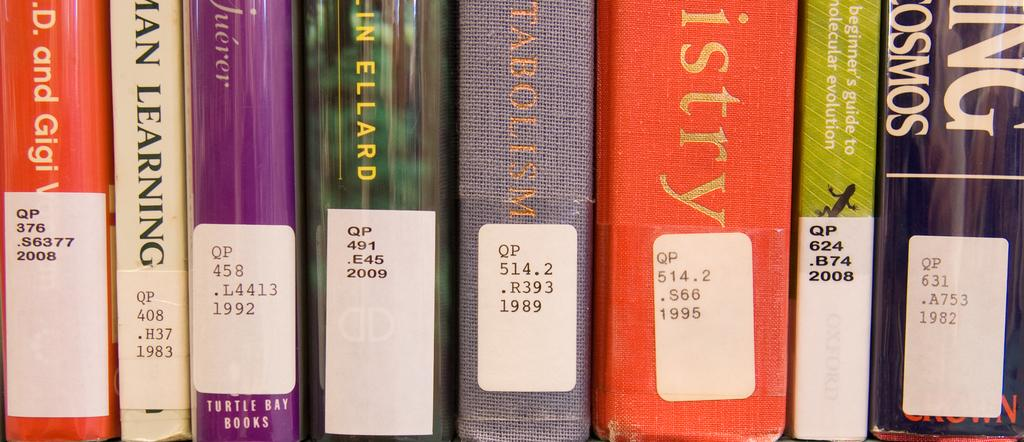<image>
Present a compact description of the photo's key features. The call numbers of library books about learning are shown. 